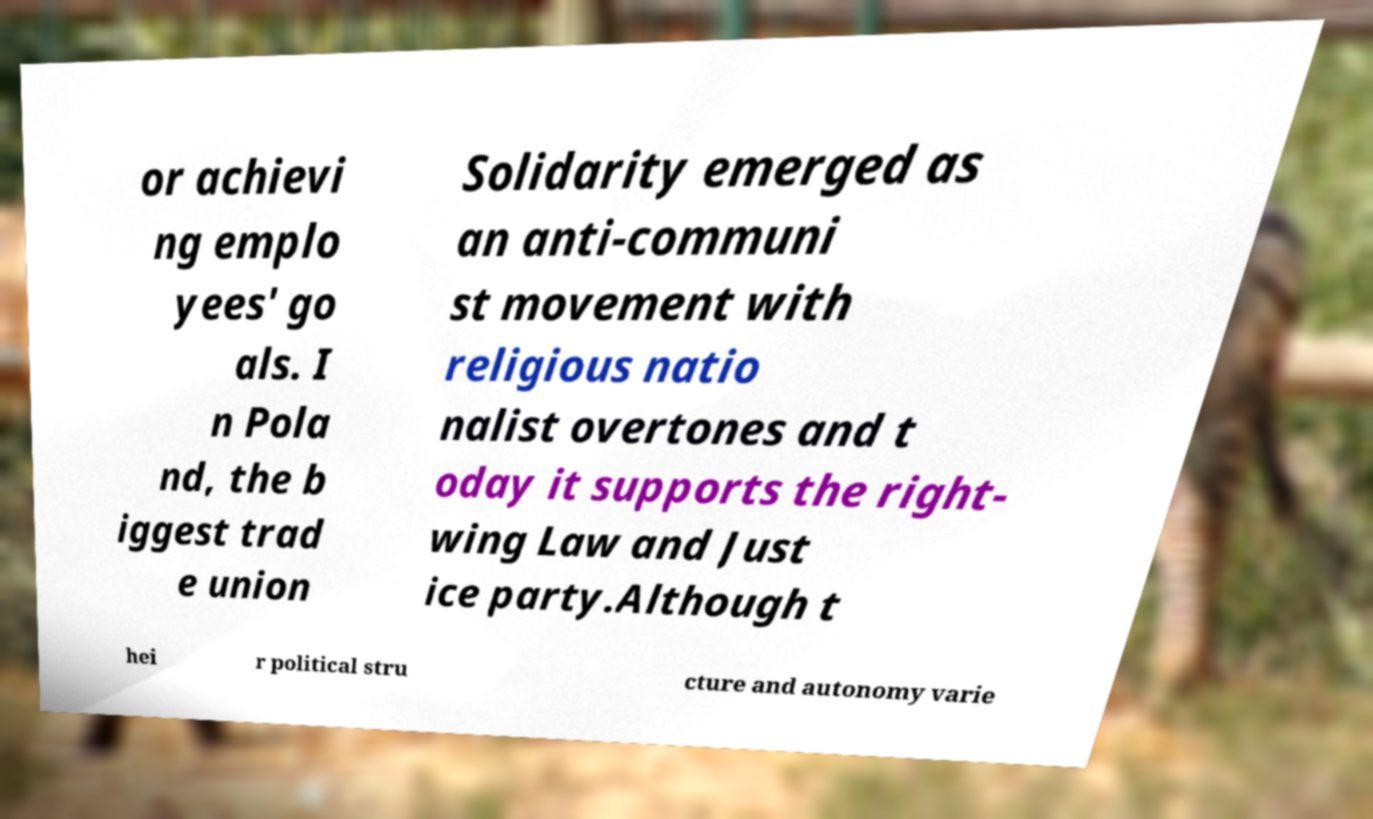There's text embedded in this image that I need extracted. Can you transcribe it verbatim? or achievi ng emplo yees' go als. I n Pola nd, the b iggest trad e union Solidarity emerged as an anti-communi st movement with religious natio nalist overtones and t oday it supports the right- wing Law and Just ice party.Although t hei r political stru cture and autonomy varie 